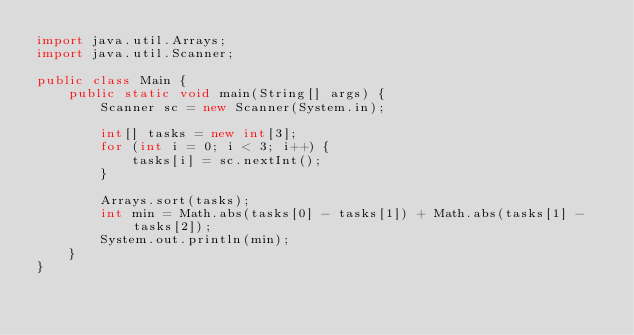<code> <loc_0><loc_0><loc_500><loc_500><_Java_>import java.util.Arrays;
import java.util.Scanner;

public class Main {
    public static void main(String[] args) {
        Scanner sc = new Scanner(System.in);

        int[] tasks = new int[3];
        for (int i = 0; i < 3; i++) {
            tasks[i] = sc.nextInt();
        }

        Arrays.sort(tasks);
        int min = Math.abs(tasks[0] - tasks[1]) + Math.abs(tasks[1] - tasks[2]);
        System.out.println(min);
    }
}
</code> 